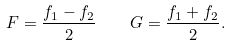Convert formula to latex. <formula><loc_0><loc_0><loc_500><loc_500>F = \frac { f _ { 1 } - f _ { 2 } } { 2 } \quad G = \frac { f _ { 1 } + f _ { 2 } } { 2 } .</formula> 